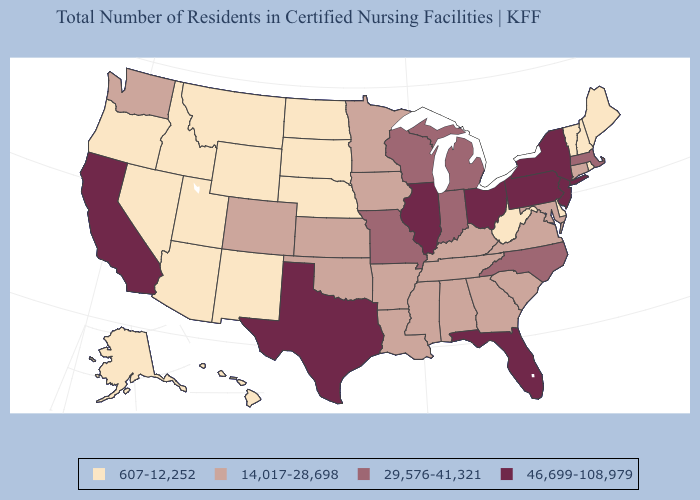Is the legend a continuous bar?
Keep it brief. No. Name the states that have a value in the range 46,699-108,979?
Short answer required. California, Florida, Illinois, New Jersey, New York, Ohio, Pennsylvania, Texas. Which states have the lowest value in the West?
Quick response, please. Alaska, Arizona, Hawaii, Idaho, Montana, Nevada, New Mexico, Oregon, Utah, Wyoming. Does Missouri have the lowest value in the USA?
Answer briefly. No. Does Maryland have the lowest value in the USA?
Be succinct. No. Name the states that have a value in the range 29,576-41,321?
Concise answer only. Indiana, Massachusetts, Michigan, Missouri, North Carolina, Wisconsin. Does Nebraska have the same value as Maine?
Be succinct. Yes. Does West Virginia have the lowest value in the South?
Write a very short answer. Yes. Is the legend a continuous bar?
Answer briefly. No. What is the value of Missouri?
Concise answer only. 29,576-41,321. Name the states that have a value in the range 607-12,252?
Answer briefly. Alaska, Arizona, Delaware, Hawaii, Idaho, Maine, Montana, Nebraska, Nevada, New Hampshire, New Mexico, North Dakota, Oregon, Rhode Island, South Dakota, Utah, Vermont, West Virginia, Wyoming. What is the value of Michigan?
Short answer required. 29,576-41,321. Does the map have missing data?
Give a very brief answer. No. Name the states that have a value in the range 29,576-41,321?
Write a very short answer. Indiana, Massachusetts, Michigan, Missouri, North Carolina, Wisconsin. Does Vermont have a higher value than Arizona?
Give a very brief answer. No. 